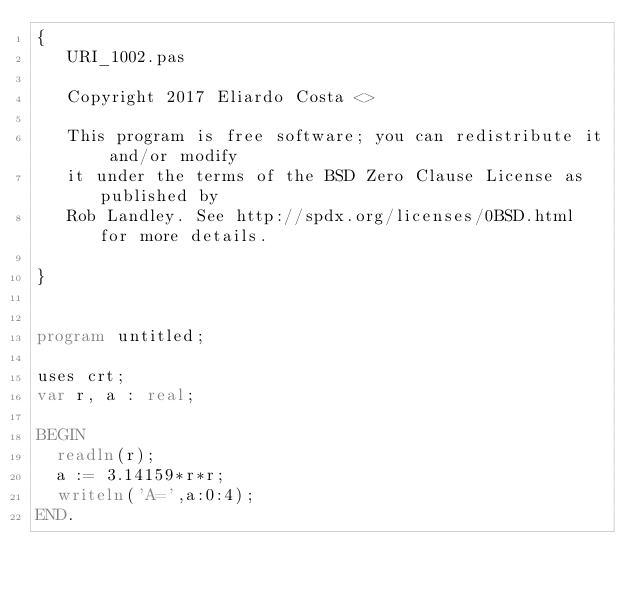Convert code to text. <code><loc_0><loc_0><loc_500><loc_500><_Pascal_>{
   URI_1002.pas
   
   Copyright 2017 Eliardo Costa <>
   
   This program is free software; you can redistribute it and/or modify
   it under the terms of the BSD Zero Clause License as published by
   Rob Landley. See http://spdx.org/licenses/0BSD.html for more details.
   
}


program untitled;

uses crt;
var r, a : real;

BEGIN
	readln(r);
	a := 3.14159*r*r;
	writeln('A=',a:0:4);
END.

</code> 